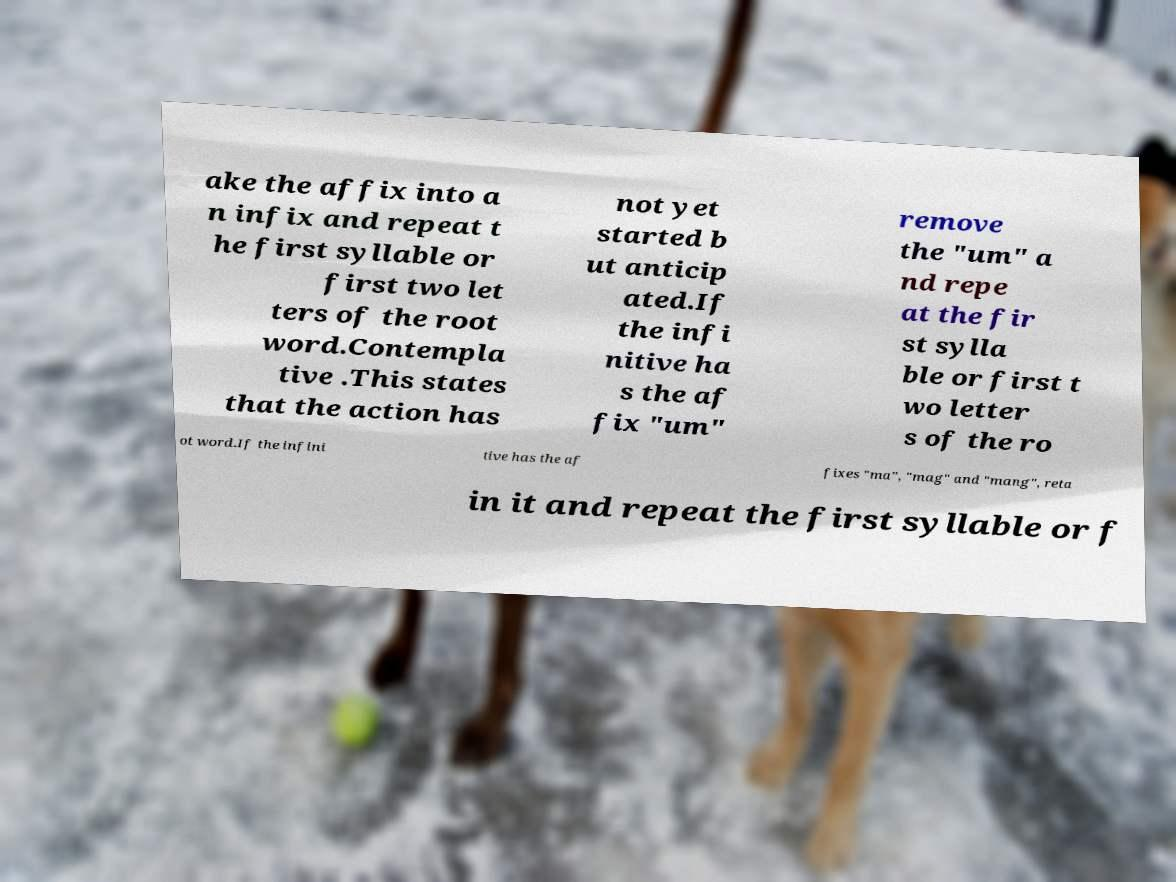Please read and relay the text visible in this image. What does it say? ake the affix into a n infix and repeat t he first syllable or first two let ters of the root word.Contempla tive .This states that the action has not yet started b ut anticip ated.If the infi nitive ha s the af fix "um" remove the "um" a nd repe at the fir st sylla ble or first t wo letter s of the ro ot word.If the infini tive has the af fixes "ma", "mag" and "mang", reta in it and repeat the first syllable or f 